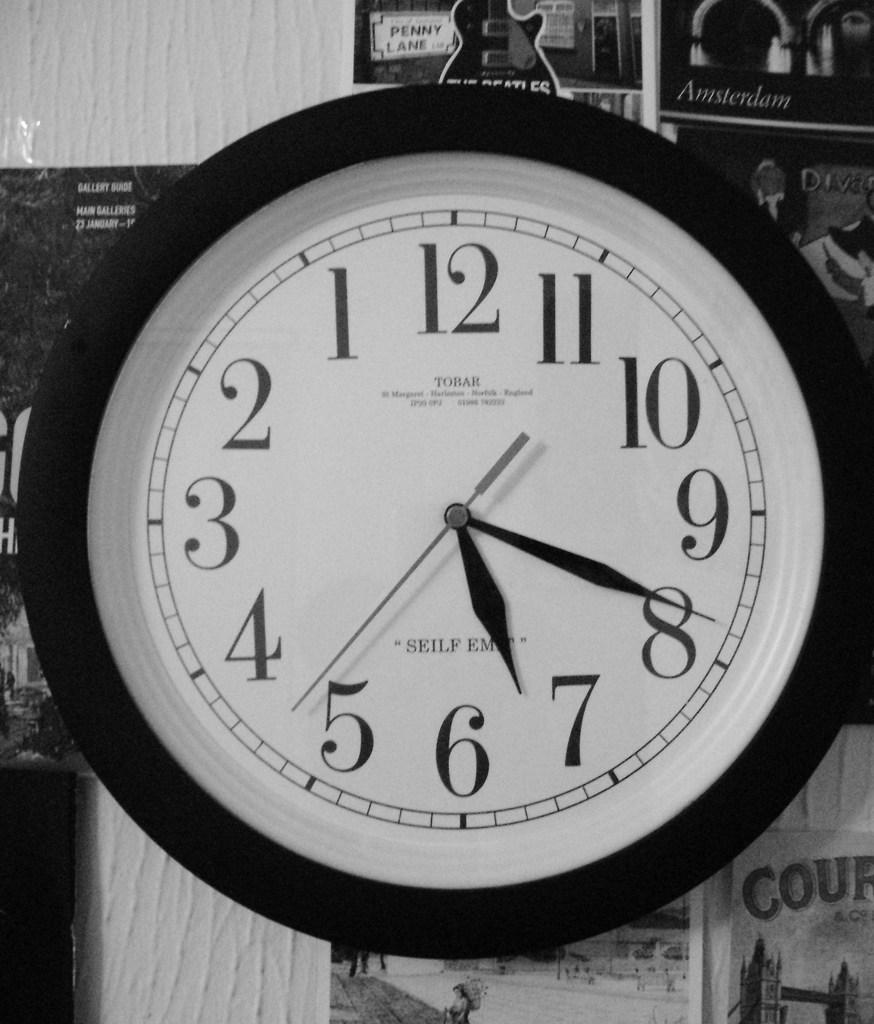<image>
Render a clear and concise summary of the photo. A Tobar clock shows that the current time is 7:19. 